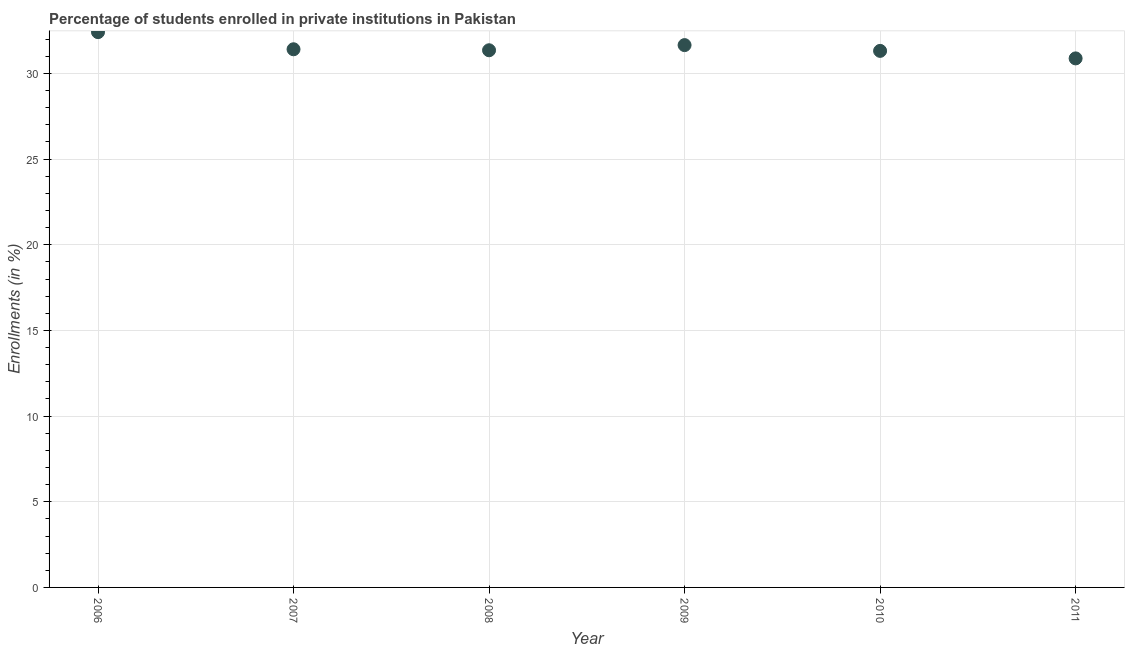What is the enrollments in private institutions in 2006?
Offer a very short reply. 32.41. Across all years, what is the maximum enrollments in private institutions?
Your response must be concise. 32.41. Across all years, what is the minimum enrollments in private institutions?
Offer a very short reply. 30.88. In which year was the enrollments in private institutions maximum?
Your response must be concise. 2006. What is the sum of the enrollments in private institutions?
Your response must be concise. 189.02. What is the difference between the enrollments in private institutions in 2008 and 2009?
Offer a very short reply. -0.3. What is the average enrollments in private institutions per year?
Ensure brevity in your answer.  31.5. What is the median enrollments in private institutions?
Provide a short and direct response. 31.38. In how many years, is the enrollments in private institutions greater than 3 %?
Make the answer very short. 6. Do a majority of the years between 2009 and 2007 (inclusive) have enrollments in private institutions greater than 2 %?
Your answer should be compact. No. What is the ratio of the enrollments in private institutions in 2006 to that in 2009?
Provide a succinct answer. 1.02. Is the enrollments in private institutions in 2006 less than that in 2009?
Provide a short and direct response. No. Is the difference between the enrollments in private institutions in 2007 and 2011 greater than the difference between any two years?
Your answer should be very brief. No. What is the difference between the highest and the second highest enrollments in private institutions?
Offer a terse response. 0.76. What is the difference between the highest and the lowest enrollments in private institutions?
Provide a succinct answer. 1.53. Does the enrollments in private institutions monotonically increase over the years?
Provide a short and direct response. No. How many years are there in the graph?
Offer a terse response. 6. What is the difference between two consecutive major ticks on the Y-axis?
Your answer should be compact. 5. Are the values on the major ticks of Y-axis written in scientific E-notation?
Your answer should be compact. No. Does the graph contain any zero values?
Your response must be concise. No. What is the title of the graph?
Give a very brief answer. Percentage of students enrolled in private institutions in Pakistan. What is the label or title of the X-axis?
Give a very brief answer. Year. What is the label or title of the Y-axis?
Make the answer very short. Enrollments (in %). What is the Enrollments (in %) in 2006?
Offer a terse response. 32.41. What is the Enrollments (in %) in 2007?
Provide a short and direct response. 31.41. What is the Enrollments (in %) in 2008?
Keep it short and to the point. 31.35. What is the Enrollments (in %) in 2009?
Your response must be concise. 31.65. What is the Enrollments (in %) in 2010?
Offer a terse response. 31.32. What is the Enrollments (in %) in 2011?
Provide a succinct answer. 30.88. What is the difference between the Enrollments (in %) in 2006 and 2007?
Provide a short and direct response. 1. What is the difference between the Enrollments (in %) in 2006 and 2008?
Provide a short and direct response. 1.06. What is the difference between the Enrollments (in %) in 2006 and 2009?
Make the answer very short. 0.76. What is the difference between the Enrollments (in %) in 2006 and 2010?
Make the answer very short. 1.09. What is the difference between the Enrollments (in %) in 2006 and 2011?
Ensure brevity in your answer.  1.53. What is the difference between the Enrollments (in %) in 2007 and 2008?
Provide a succinct answer. 0.06. What is the difference between the Enrollments (in %) in 2007 and 2009?
Keep it short and to the point. -0.24. What is the difference between the Enrollments (in %) in 2007 and 2010?
Provide a short and direct response. 0.09. What is the difference between the Enrollments (in %) in 2007 and 2011?
Your response must be concise. 0.53. What is the difference between the Enrollments (in %) in 2008 and 2009?
Provide a short and direct response. -0.3. What is the difference between the Enrollments (in %) in 2008 and 2010?
Give a very brief answer. 0.04. What is the difference between the Enrollments (in %) in 2008 and 2011?
Provide a short and direct response. 0.47. What is the difference between the Enrollments (in %) in 2009 and 2010?
Ensure brevity in your answer.  0.34. What is the difference between the Enrollments (in %) in 2009 and 2011?
Your answer should be very brief. 0.78. What is the difference between the Enrollments (in %) in 2010 and 2011?
Keep it short and to the point. 0.44. What is the ratio of the Enrollments (in %) in 2006 to that in 2007?
Your answer should be very brief. 1.03. What is the ratio of the Enrollments (in %) in 2006 to that in 2008?
Your answer should be compact. 1.03. What is the ratio of the Enrollments (in %) in 2006 to that in 2009?
Offer a terse response. 1.02. What is the ratio of the Enrollments (in %) in 2006 to that in 2010?
Give a very brief answer. 1.03. What is the ratio of the Enrollments (in %) in 2007 to that in 2009?
Ensure brevity in your answer.  0.99. What is the ratio of the Enrollments (in %) in 2007 to that in 2011?
Make the answer very short. 1.02. What is the ratio of the Enrollments (in %) in 2008 to that in 2009?
Provide a succinct answer. 0.99. What is the ratio of the Enrollments (in %) in 2008 to that in 2010?
Your answer should be very brief. 1. What is the ratio of the Enrollments (in %) in 2009 to that in 2010?
Offer a very short reply. 1.01. 